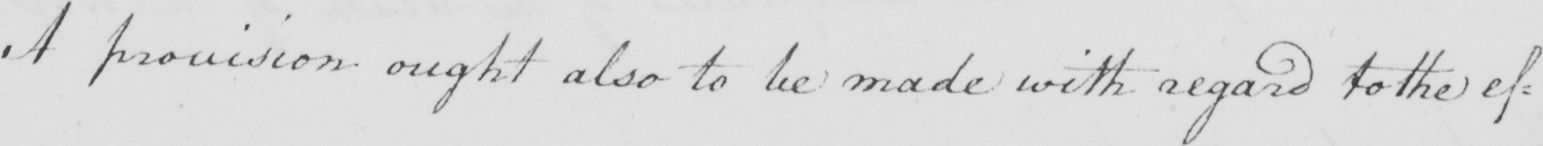Please provide the text content of this handwritten line. A provision ought also to be made with regard to the ef= 